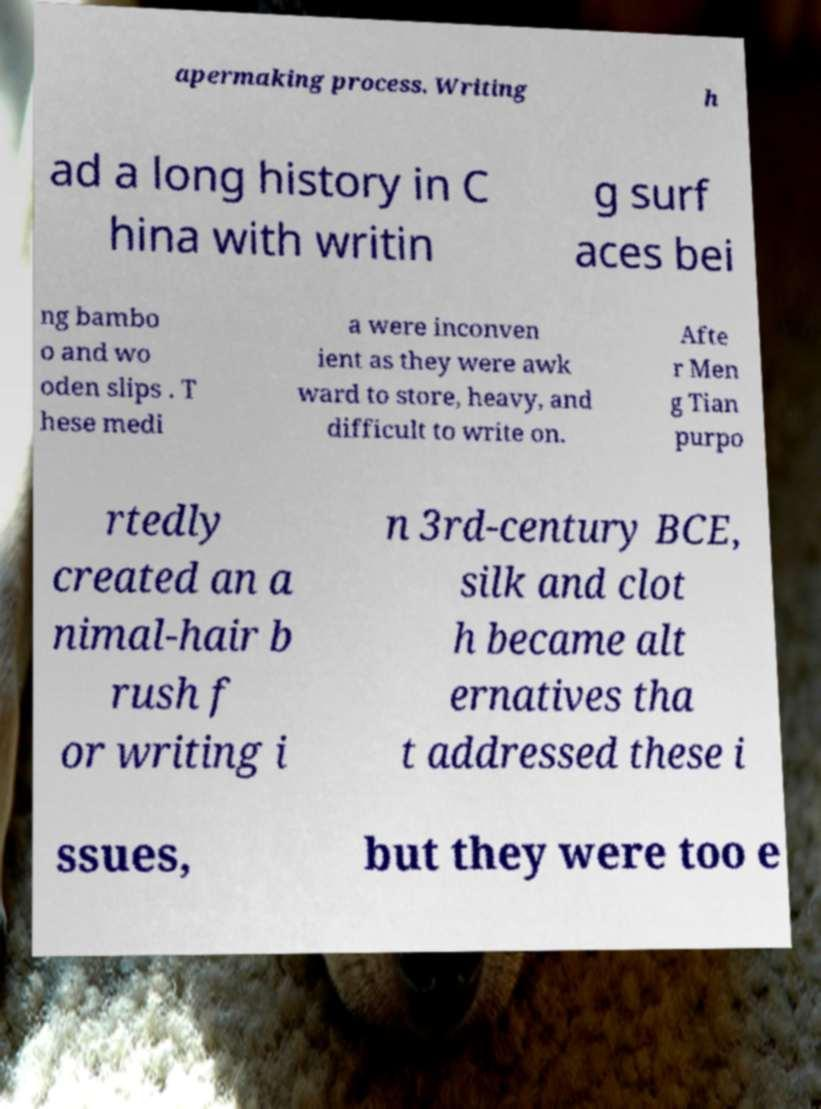What messages or text are displayed in this image? I need them in a readable, typed format. apermaking process. Writing h ad a long history in C hina with writin g surf aces bei ng bambo o and wo oden slips . T hese medi a were inconven ient as they were awk ward to store, heavy, and difficult to write on. Afte r Men g Tian purpo rtedly created an a nimal-hair b rush f or writing i n 3rd-century BCE, silk and clot h became alt ernatives tha t addressed these i ssues, but they were too e 